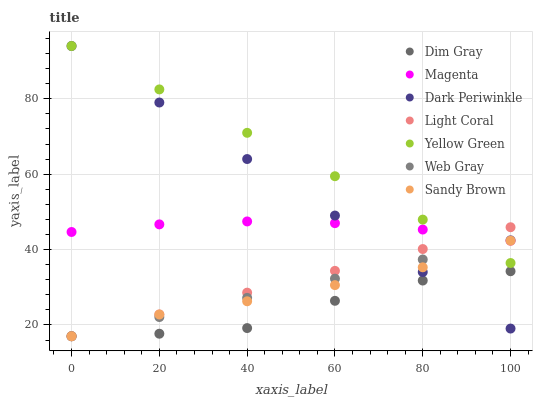Does Dim Gray have the minimum area under the curve?
Answer yes or no. Yes. Does Yellow Green have the maximum area under the curve?
Answer yes or no. Yes. Does Light Coral have the minimum area under the curve?
Answer yes or no. No. Does Light Coral have the maximum area under the curve?
Answer yes or no. No. Is Web Gray the smoothest?
Answer yes or no. Yes. Is Dim Gray the roughest?
Answer yes or no. Yes. Is Yellow Green the smoothest?
Answer yes or no. No. Is Yellow Green the roughest?
Answer yes or no. No. Does Dim Gray have the lowest value?
Answer yes or no. Yes. Does Yellow Green have the lowest value?
Answer yes or no. No. Does Dark Periwinkle have the highest value?
Answer yes or no. Yes. Does Light Coral have the highest value?
Answer yes or no. No. Is Sandy Brown less than Magenta?
Answer yes or no. Yes. Is Yellow Green greater than Dim Gray?
Answer yes or no. Yes. Does Sandy Brown intersect Dim Gray?
Answer yes or no. Yes. Is Sandy Brown less than Dim Gray?
Answer yes or no. No. Is Sandy Brown greater than Dim Gray?
Answer yes or no. No. Does Sandy Brown intersect Magenta?
Answer yes or no. No. 